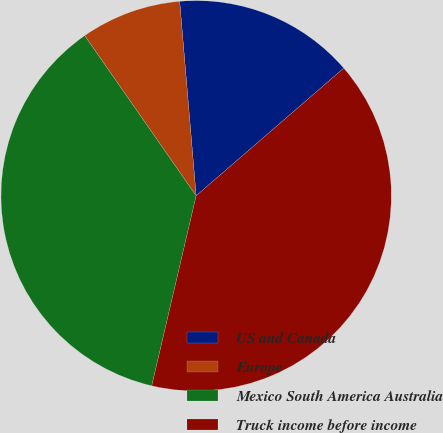Convert chart. <chart><loc_0><loc_0><loc_500><loc_500><pie_chart><fcel>US and Canada<fcel>Europe<fcel>Mexico South America Australia<fcel>Truck income before income<nl><fcel>15.0%<fcel>8.33%<fcel>36.67%<fcel>40.0%<nl></chart> 